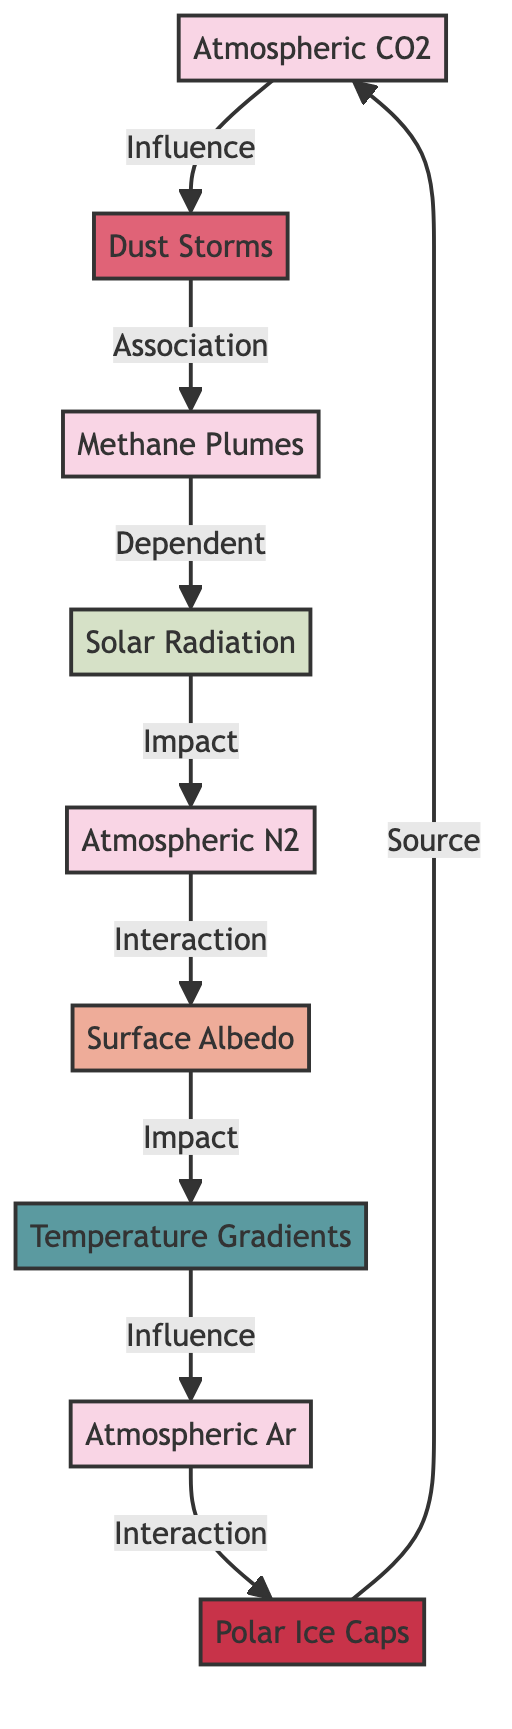What's the primary component of the Martian atmosphere? The diagram indicates that Atmospheric CO2 is the primary component, constituting about 95.3% of the Martian atmosphere.
Answer: Atmospheric CO2 How many nodes are present in the diagram? The diagram lists 9 nodes, each representing different components or features related to the Martian atmosphere and surface.
Answer: 9 What is the relationship between Atmospheric N2 and Surface Albedo? The diagram shows an Interaction relationship between Atmospheric N2 and Surface Albedo, indicating they influence one another, specifically affecting surface temperature.
Answer: Interaction Which element is linked to temperature gradients? Temperature Gradients are influenced by Surface Albedo according to the diagram, revealing that differences in surface reflectivity contribute to variations in temperature across Martian regions.
Answer: Surface Albedo What gas is released from Polar Ice Caps? The diagram specifies that Polar Ice Caps are a source of Atmospheric CO2 due to seasonal sublimation processes that release CO2 into the atmosphere.
Answer: Atmospheric CO2 How do Dust Storms relate to Methane Plumes? The diagram illustrates an Association between Dust Storms and Methane Plumes, suggesting that powerful dust storms may be linked to the release of localized methane emissions.
Answer: Association What impact does Solar Radiation have on Atmospheric N2? In the diagram, Solar Radiation affects Atmospheric N2 by impacting nitric oxide formation and dissociation, showing a direct influence on its levels in the Martian atmosphere.
Answer: Impact What influences Argon distribution in the atmosphere? The diagram indicates that Temperature Gradients affect Atmospheric Ar distribution, establishing a connection between temperature variations and the presence of argon gas in different regions.
Answer: Temperature Gradients How does Atmospheric CO2 impact Dust Storms? The diagram depicts an Influence connection from Atmospheric CO2 to Dust Storms, showing that levels of CO2 can affect the intensity and frequency of these meteorological phenomena.
Answer: Influence 